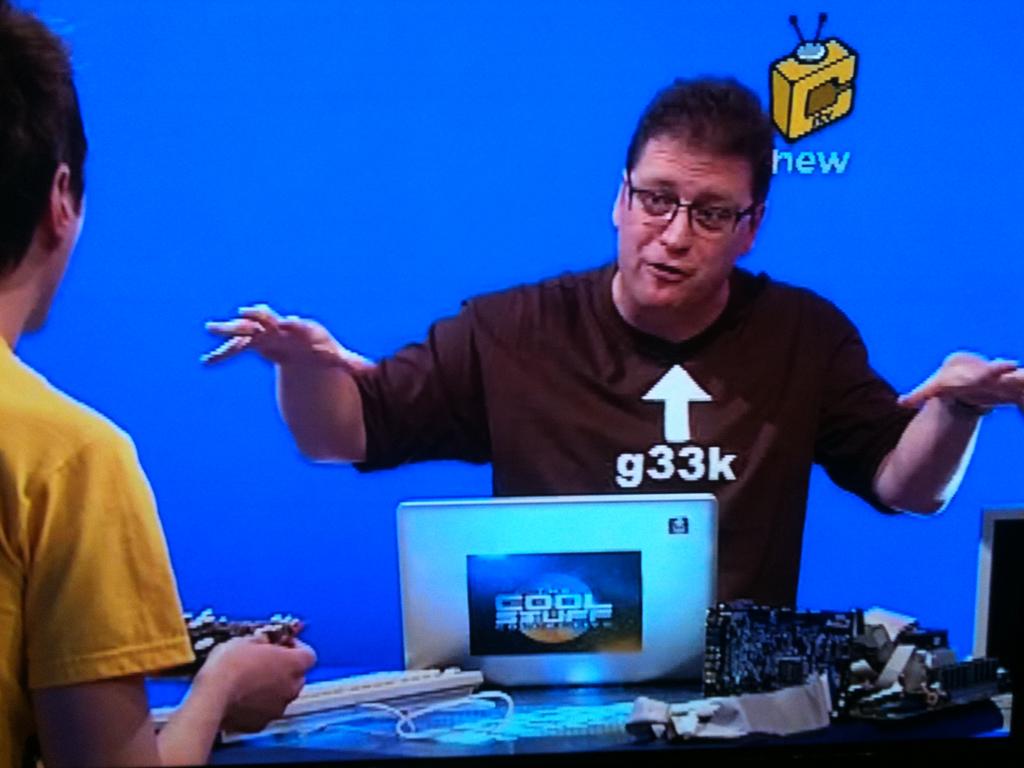What does the man's shirt say he is?
Offer a terse response. G33k. What does the picture/sticker on the laptop say?
Ensure brevity in your answer.  Cool stuff. 